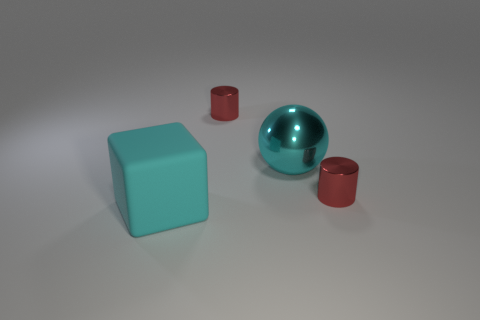Can you describe the lighting and mood of this scene? The lighting in the scene is soft and diffused, creating a tranquil and serene mood. There are no harsh shadows, and the light source seems to be coming from above, as indicated by the soft shadows directly underneath the objects. 